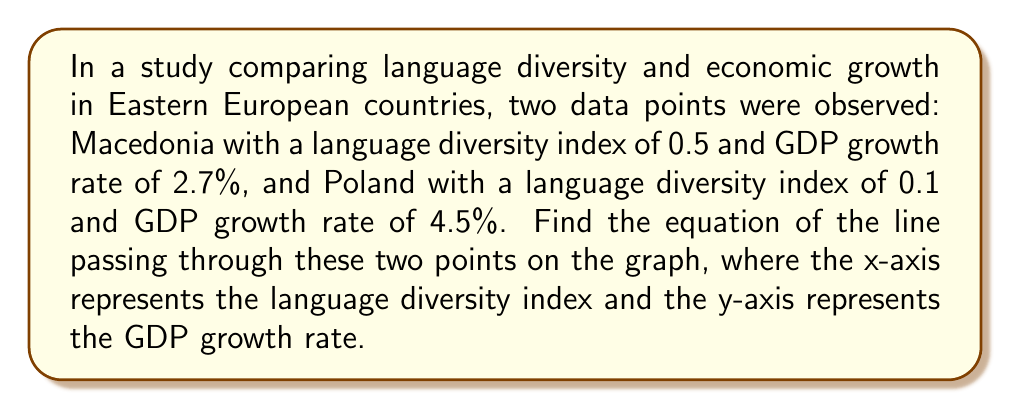Can you solve this math problem? To find the equation of a line passing through two points, we'll use the point-slope form of a line: $y - y_1 = m(x - x_1)$, where $m$ is the slope.

Step 1: Identify the coordinates of the two points:
Point 1 (Macedonia): $(x_1, y_1) = (0.5, 2.7)$
Point 2 (Poland): $(x_2, y_2) = (0.1, 4.5)$

Step 2: Calculate the slope $m$ using the slope formula:
$m = \frac{y_2 - y_1}{x_2 - x_1} = \frac{4.5 - 2.7}{0.1 - 0.5} = \frac{1.8}{-0.4} = -4.5$

Step 3: Use the point-slope form with either point. Let's use Macedonia's point (0.5, 2.7):
$y - 2.7 = -4.5(x - 0.5)$

Step 4: Distribute the -4.5:
$y - 2.7 = -4.5x + 2.25$

Step 5: Add 2.7 to both sides to get the equation in slope-intercept form:
$y = -4.5x + 4.95$

Therefore, the equation of the line passing through these two points is $y = -4.5x + 4.95$.
Answer: $y = -4.5x + 4.95$ 